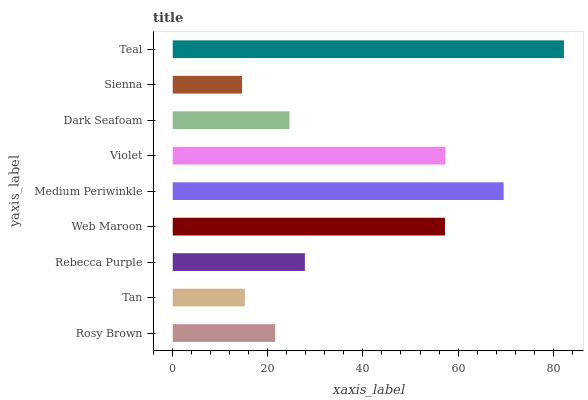Is Sienna the minimum?
Answer yes or no. Yes. Is Teal the maximum?
Answer yes or no. Yes. Is Tan the minimum?
Answer yes or no. No. Is Tan the maximum?
Answer yes or no. No. Is Rosy Brown greater than Tan?
Answer yes or no. Yes. Is Tan less than Rosy Brown?
Answer yes or no. Yes. Is Tan greater than Rosy Brown?
Answer yes or no. No. Is Rosy Brown less than Tan?
Answer yes or no. No. Is Rebecca Purple the high median?
Answer yes or no. Yes. Is Rebecca Purple the low median?
Answer yes or no. Yes. Is Rosy Brown the high median?
Answer yes or no. No. Is Sienna the low median?
Answer yes or no. No. 